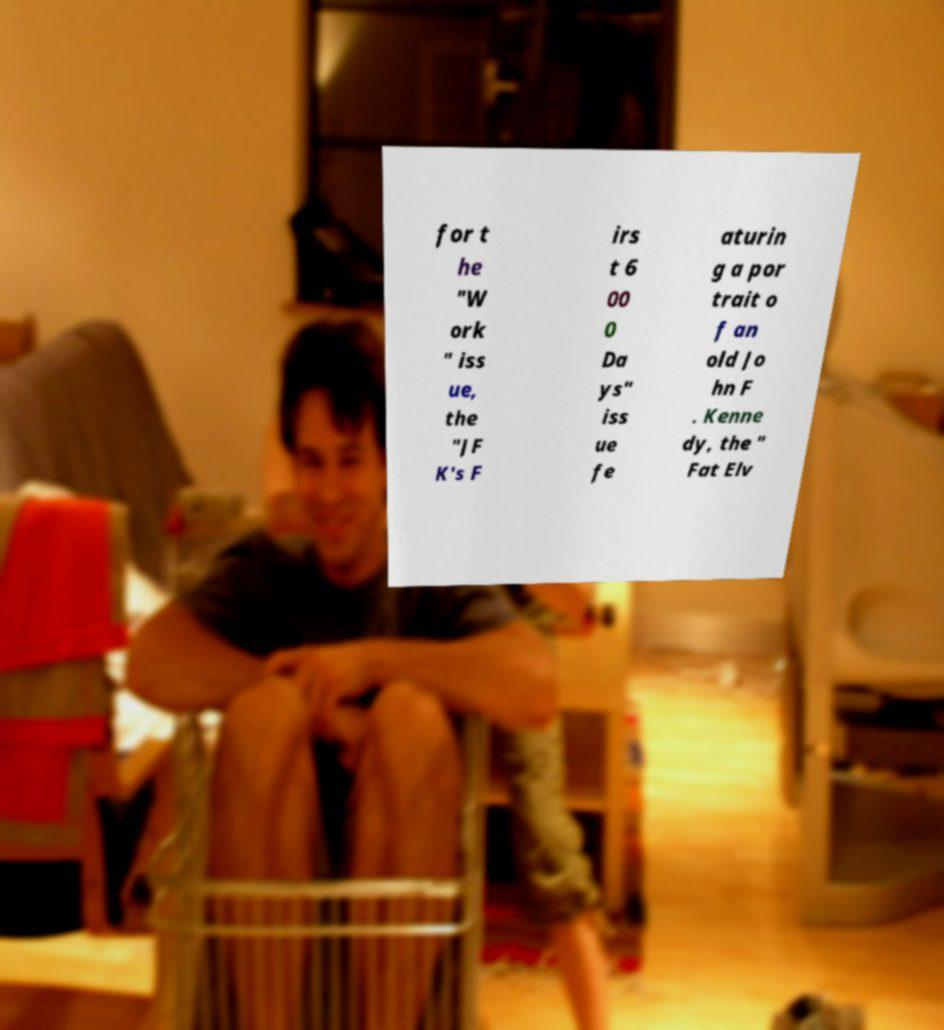Can you read and provide the text displayed in the image?This photo seems to have some interesting text. Can you extract and type it out for me? for t he "W ork " iss ue, the "JF K's F irs t 6 00 0 Da ys" iss ue fe aturin g a por trait o f an old Jo hn F . Kenne dy, the " Fat Elv 